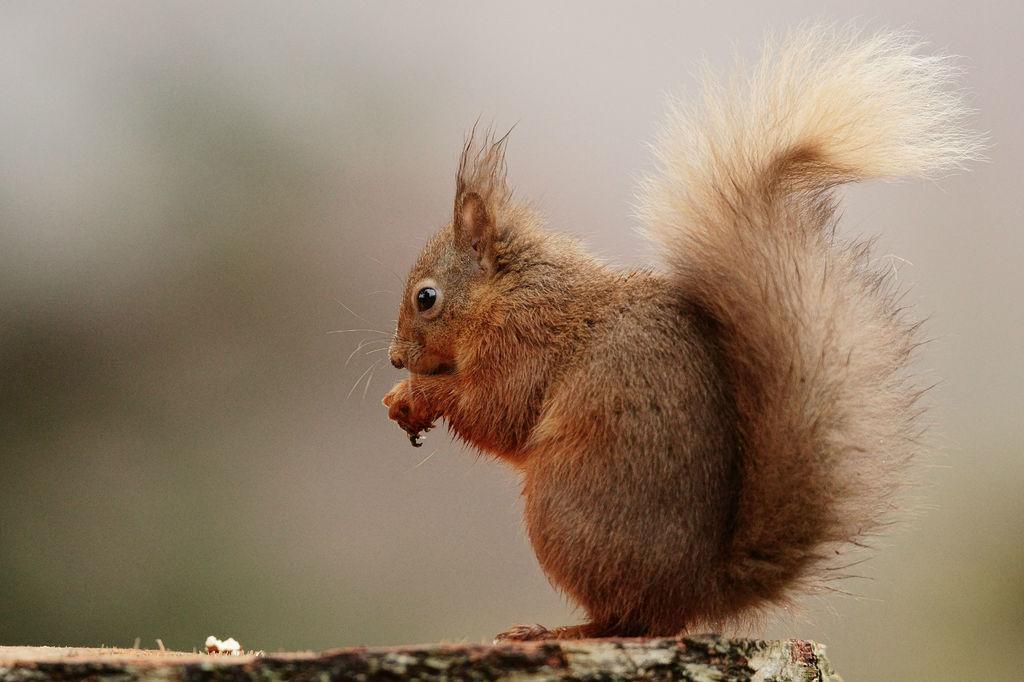Could you give a brief overview of what you see in this image? This picture is clicked outside. On the right there is a squirrel standing on an object. The background of the image is blurry. 